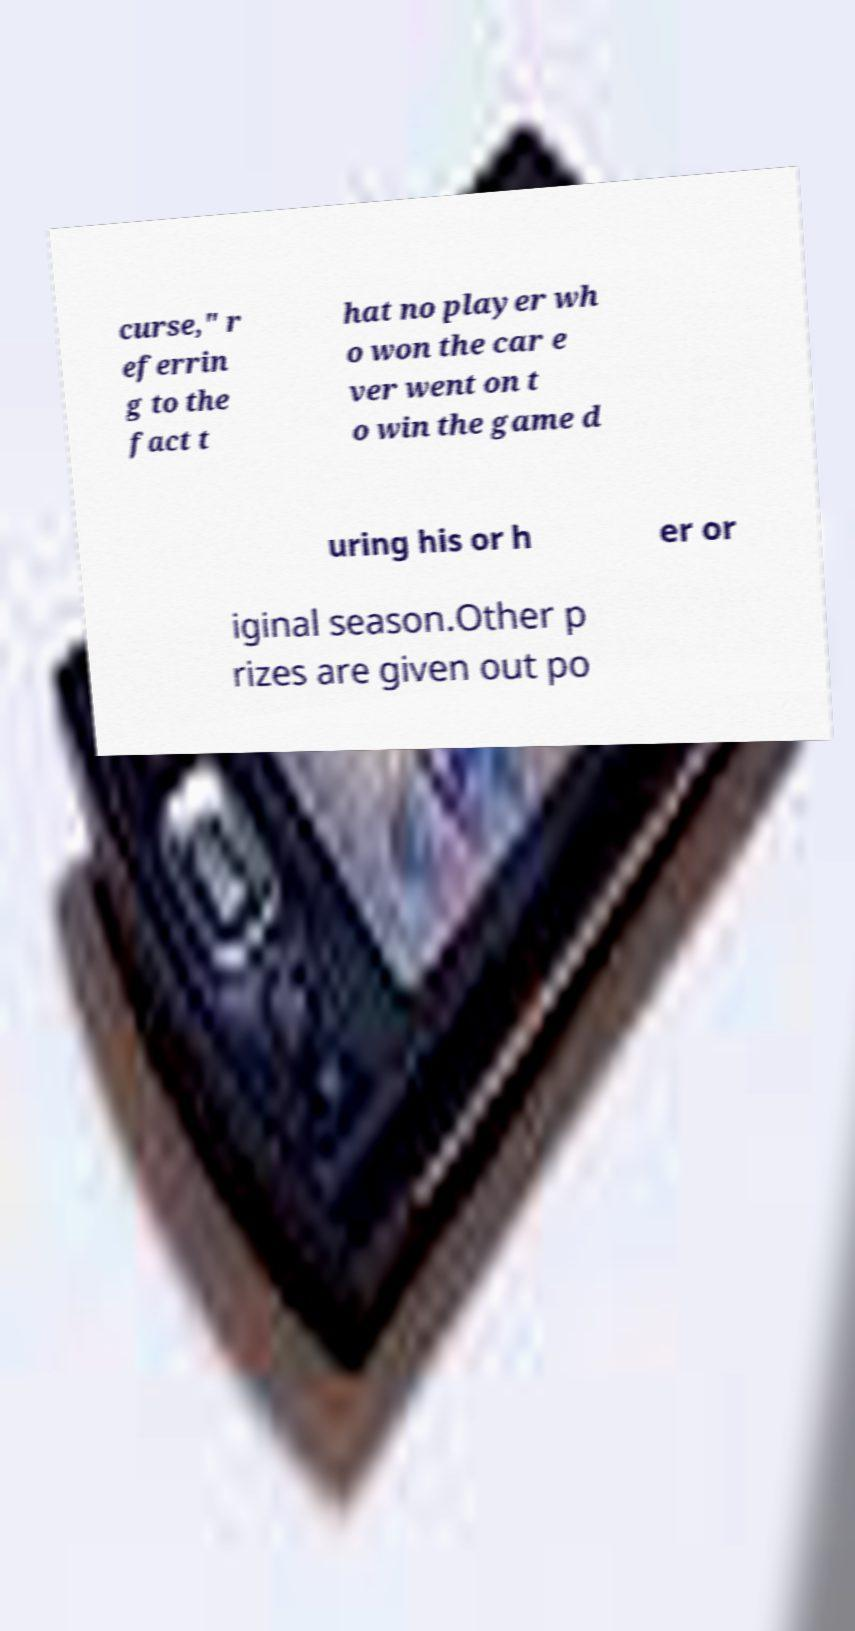Please identify and transcribe the text found in this image. curse," r eferrin g to the fact t hat no player wh o won the car e ver went on t o win the game d uring his or h er or iginal season.Other p rizes are given out po 